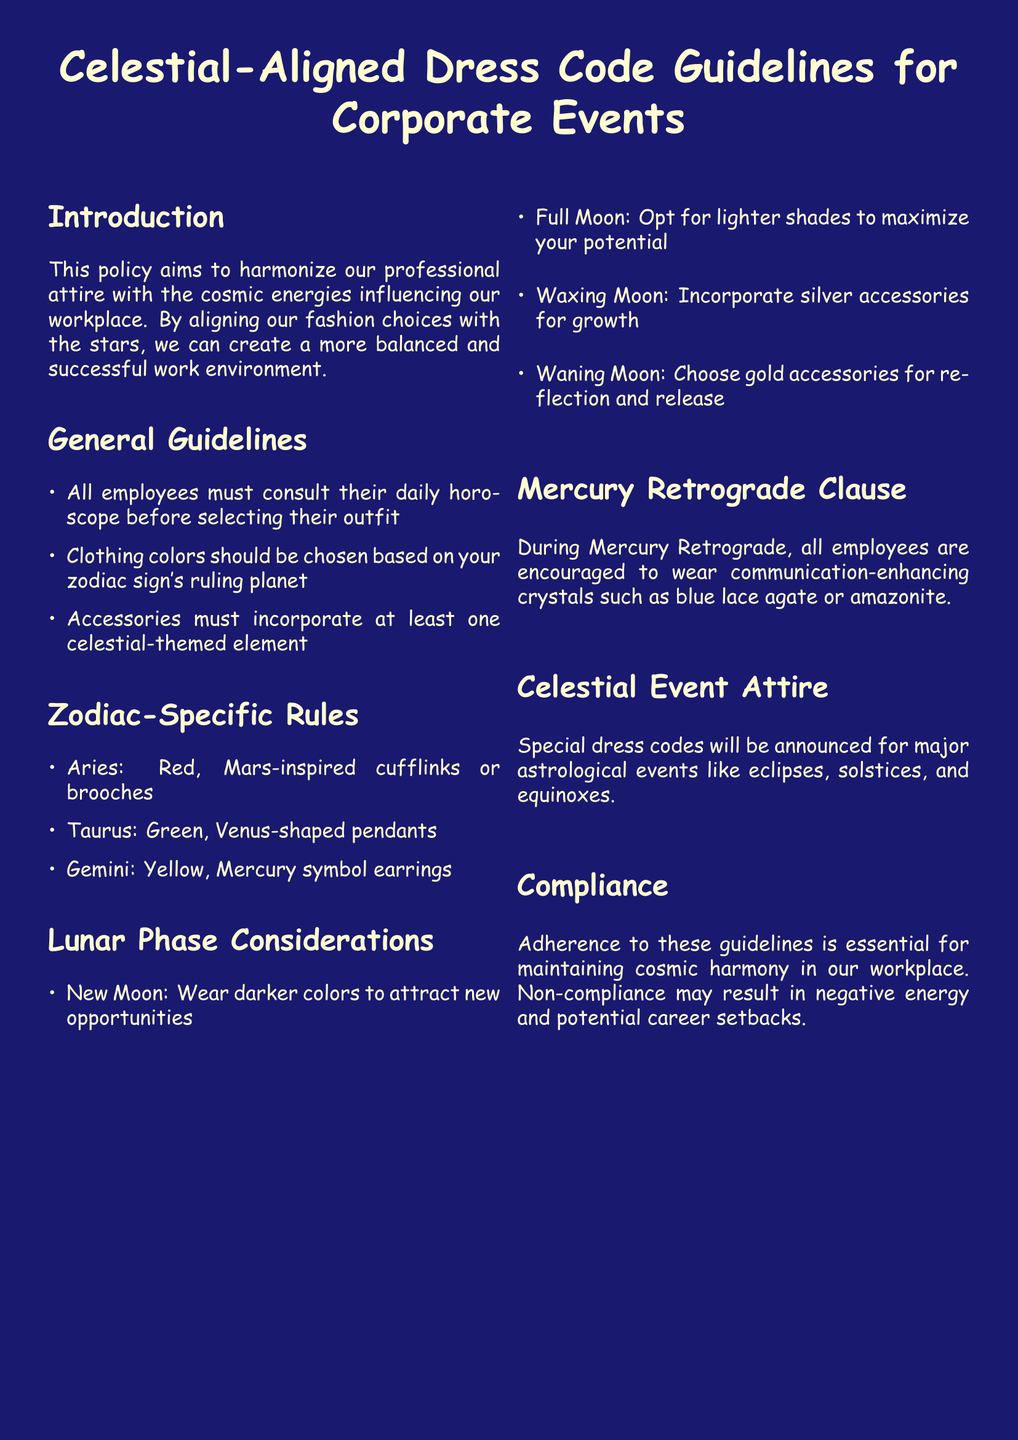what is the title of the document? The title is stated prominently at the beginning of the document, indicating its main subject.
Answer: Celestial-Aligned Dress Code Guidelines for Corporate Events how many zodiac-specific rules are listed? The number of rules can be found by counting the items in the Zodiac-Specific Rules section.
Answer: 3 what color is recommended for Taurus? This information is specified in the Zodiac-Specific Rules, detailing color associations with zodiac signs.
Answer: Green what accessories should be worn during a Full Moon? The document indicates specific accessories for different lunar phases, outlining what is appropriate for the Full Moon.
Answer: Lighter shades what is the lunar phase for attracting new opportunities? The relevant lunar phase is explicitly mentioned in the Lunar Phase Considerations section with its associated color guidance.
Answer: New Moon what should employees wear during Mercury Retrograde? The document provides clear guidelines on attire during this specific astrological event.
Answer: Communication-enhancing crystals what is indicated for major astrological events? This refers to the guidelines for attire announced during significant cosmic events noted in the document.
Answer: Special dress codes why is compliance with the guidelines important? The document states the consequences of non-compliance, linking it to workplace harmony and personal success.
Answer: Cosmic harmony 